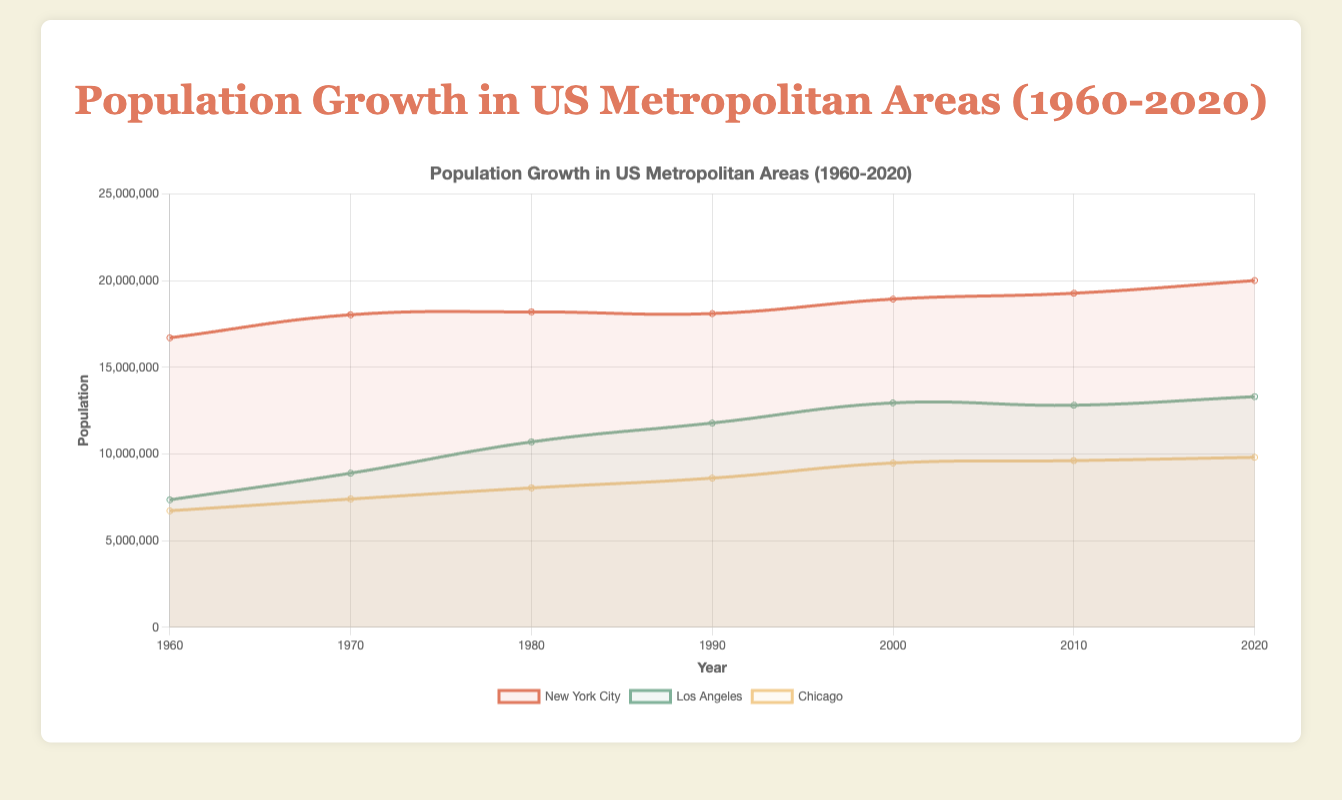What is the population difference between New York City and Los Angeles in 2020? In 2020, New York City's population is 20,010,000, and Los Angeles' population is 13,310,000. The difference is 20,010,000 - 13,310,000 = 6,700,000
Answer: 6,700,000 Which metropolitan area had the highest population growth from 1960 to 2020? Compare the population increases for New York City, Los Angeles, and Chicago over the period from 1960 to 2020. New York City's population grew from 16,708,000 to 20,010,000 (an increase of 3,302,000), Los Angeles' population grew from 7,357,600 to 13,310,000 (an increase of 5,952,400), and Chicago's population grew from 6,725,600 to 9,811,000 (an increase of 3,085,400). The highest population growth is in Los Angeles.
Answer: Los Angeles What is the average migration gain for Chicago between 1970 and 2020? Calculate the migration gains for Chicago for the years 1970, 1980, 1990, 2000, 2010, and 2020, and then find the average: (677,300 + 640,100 + 566,000 + 873,325 + 136,236 + 192,438) / 6 = 3,085,399 / 6 ≈ 514,233
Answer: 514,233 Which metropolitan area experienced a negative migration gain in 2010? Look at the data for 2010 to find which metropolitan area had a negative migration gain. Los Angeles had a migration gain of -135,525 in 2010.
Answer: Los Angeles How did the migration gains in New York City and Chicago compare between 1960 and 2020? In 1960, migration data is not provided; thus, consider from 1970 onwards. By comparing the sum of migration gains for New York City and Chicago over the years, we see: New York City's migration gain is the sum of (1,328,600 + 164,400 - 95,000 + 835,700 + 338,300 + 730,000) = 3,302,000; Chicago’s migration gain is the sum of (677,300 + 640,100 + 566,000 + 873,325 + 136,236 + 192,438) ≈ 3,085,399. Thus, New York City had a higher cumulative migration gain.
Answer: New York City By how much did New York City's population increase from 1960 to 1970? Subtract New York City's population in 1960 from its population in 1970: 18,036,600 - 16,708,000 = 1,328,600
Answer: 1,328,600 Which metropolitan area showed the most consistency in population growth over the study period (1960-2020)? Examine the population data over the years for New York City, Los Angeles, and Chicago. New York City's population increased steadily each decade, while Los Angeles and Chicago had more fluctuations, including some periods of negative migration gain.
Answer: New York City 